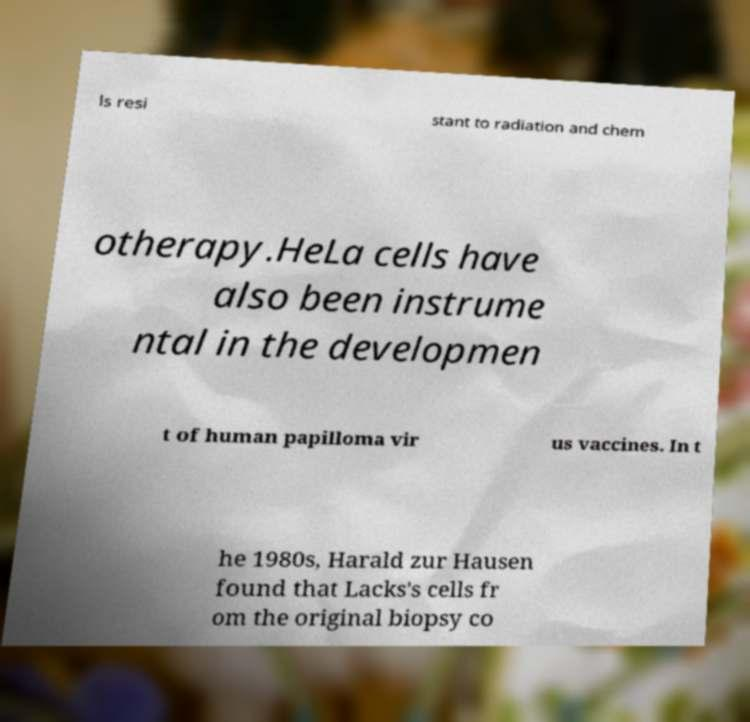Please identify and transcribe the text found in this image. ls resi stant to radiation and chem otherapy.HeLa cells have also been instrume ntal in the developmen t of human papilloma vir us vaccines. In t he 1980s, Harald zur Hausen found that Lacks's cells fr om the original biopsy co 